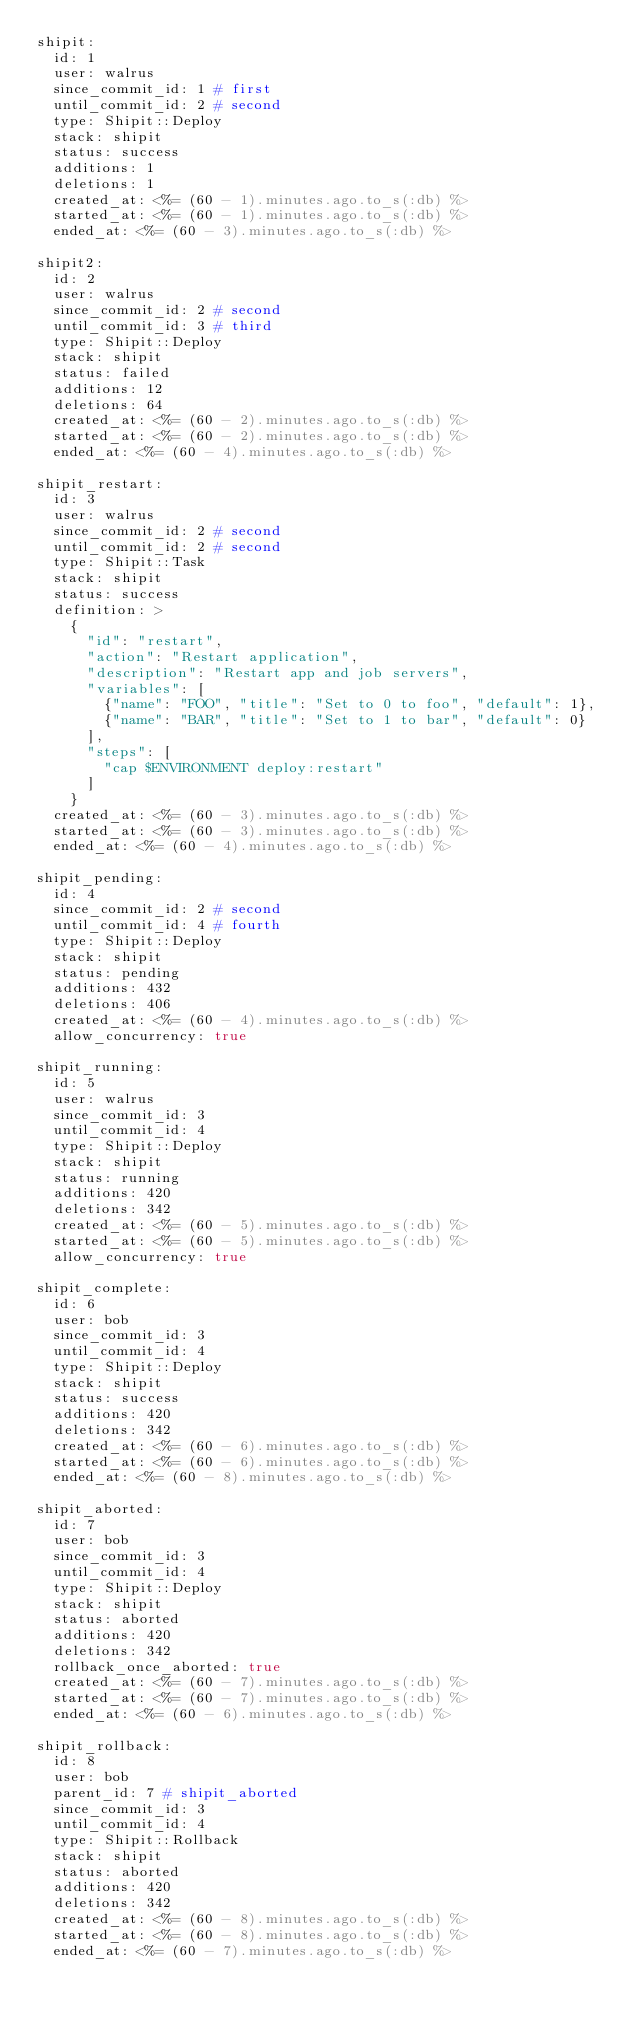<code> <loc_0><loc_0><loc_500><loc_500><_YAML_>shipit:
  id: 1
  user: walrus
  since_commit_id: 1 # first
  until_commit_id: 2 # second
  type: Shipit::Deploy
  stack: shipit
  status: success
  additions: 1
  deletions: 1
  created_at: <%= (60 - 1).minutes.ago.to_s(:db) %>
  started_at: <%= (60 - 1).minutes.ago.to_s(:db) %>
  ended_at: <%= (60 - 3).minutes.ago.to_s(:db) %>

shipit2:
  id: 2
  user: walrus
  since_commit_id: 2 # second
  until_commit_id: 3 # third
  type: Shipit::Deploy
  stack: shipit
  status: failed
  additions: 12
  deletions: 64
  created_at: <%= (60 - 2).minutes.ago.to_s(:db) %>
  started_at: <%= (60 - 2).minutes.ago.to_s(:db) %>
  ended_at: <%= (60 - 4).minutes.ago.to_s(:db) %>

shipit_restart:
  id: 3
  user: walrus
  since_commit_id: 2 # second
  until_commit_id: 2 # second
  type: Shipit::Task
  stack: shipit
  status: success
  definition: >
    {
      "id": "restart",
      "action": "Restart application",
      "description": "Restart app and job servers",
      "variables": [
        {"name": "FOO", "title": "Set to 0 to foo", "default": 1},
        {"name": "BAR", "title": "Set to 1 to bar", "default": 0}
      ],
      "steps": [
        "cap $ENVIRONMENT deploy:restart"
      ]
    }
  created_at: <%= (60 - 3).minutes.ago.to_s(:db) %>
  started_at: <%= (60 - 3).minutes.ago.to_s(:db) %>
  ended_at: <%= (60 - 4).minutes.ago.to_s(:db) %>

shipit_pending:
  id: 4
  since_commit_id: 2 # second
  until_commit_id: 4 # fourth
  type: Shipit::Deploy
  stack: shipit
  status: pending
  additions: 432
  deletions: 406
  created_at: <%= (60 - 4).minutes.ago.to_s(:db) %>
  allow_concurrency: true

shipit_running:
  id: 5
  user: walrus
  since_commit_id: 3
  until_commit_id: 4
  type: Shipit::Deploy
  stack: shipit
  status: running
  additions: 420
  deletions: 342
  created_at: <%= (60 - 5).minutes.ago.to_s(:db) %>
  started_at: <%= (60 - 5).minutes.ago.to_s(:db) %>
  allow_concurrency: true

shipit_complete:
  id: 6
  user: bob
  since_commit_id: 3
  until_commit_id: 4
  type: Shipit::Deploy
  stack: shipit
  status: success
  additions: 420
  deletions: 342
  created_at: <%= (60 - 6).minutes.ago.to_s(:db) %>
  started_at: <%= (60 - 6).minutes.ago.to_s(:db) %>
  ended_at: <%= (60 - 8).minutes.ago.to_s(:db) %>

shipit_aborted:
  id: 7
  user: bob
  since_commit_id: 3
  until_commit_id: 4
  type: Shipit::Deploy
  stack: shipit
  status: aborted
  additions: 420
  deletions: 342
  rollback_once_aborted: true
  created_at: <%= (60 - 7).minutes.ago.to_s(:db) %>
  started_at: <%= (60 - 7).minutes.ago.to_s(:db) %>
  ended_at: <%= (60 - 6).minutes.ago.to_s(:db) %>

shipit_rollback:
  id: 8
  user: bob
  parent_id: 7 # shipit_aborted
  since_commit_id: 3
  until_commit_id: 4
  type: Shipit::Rollback
  stack: shipit
  status: aborted
  additions: 420
  deletions: 342
  created_at: <%= (60 - 8).minutes.ago.to_s(:db) %>
  started_at: <%= (60 - 8).minutes.ago.to_s(:db) %>
  ended_at: <%= (60 - 7).minutes.ago.to_s(:db) %>
</code> 